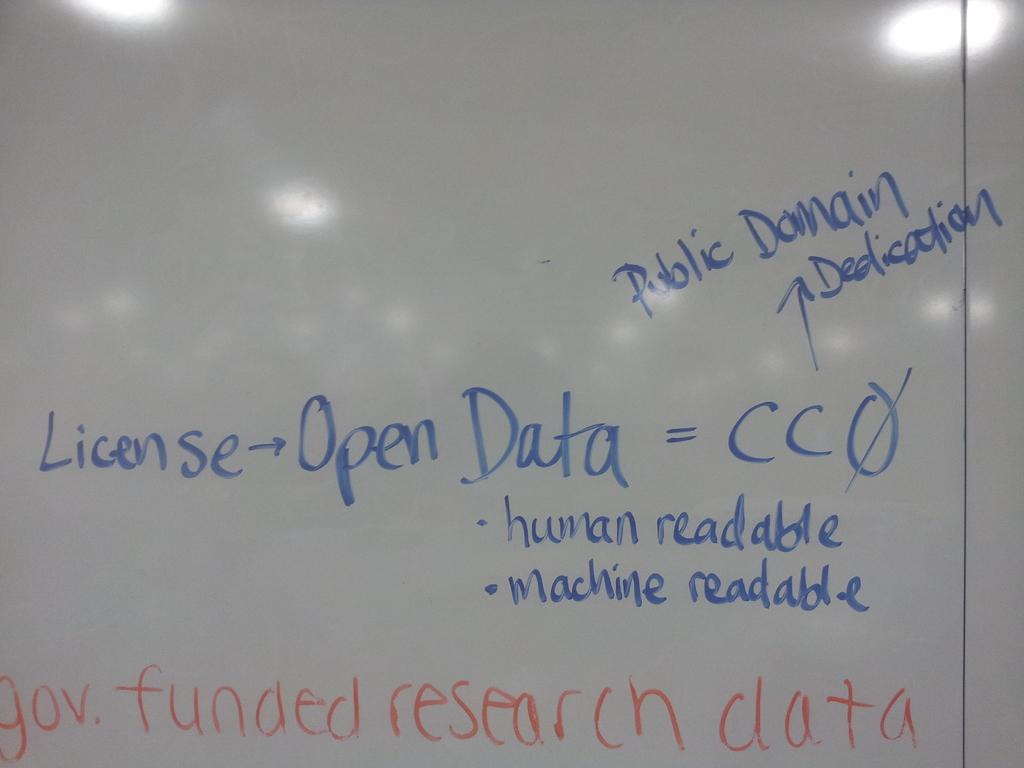<image>
Create a compact narrative representing the image presented. the word license that is on a white board 